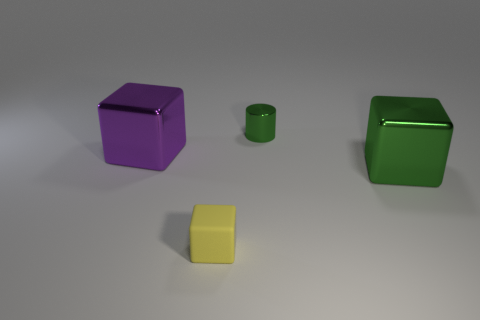What is the material of the big purple thing that is the same shape as the tiny matte object?
Provide a short and direct response. Metal. What is the small green object made of?
Your answer should be very brief. Metal. There is a green object behind the large cube that is in front of the large object to the left of the small shiny cylinder; what is it made of?
Provide a short and direct response. Metal. Is there a metallic cube that has the same color as the shiny cylinder?
Your answer should be very brief. Yes. The green cylinder is what size?
Offer a terse response. Small. Do the yellow cube and the cylinder have the same material?
Ensure brevity in your answer.  No. How many big things are on the left side of the green metal thing that is to the left of the block that is on the right side of the small matte object?
Make the answer very short. 1. There is a green thing left of the big green cube; what shape is it?
Make the answer very short. Cylinder. How many other objects are there of the same material as the yellow thing?
Ensure brevity in your answer.  0. Is the number of green objects that are in front of the big green object less than the number of purple objects that are behind the tiny cylinder?
Give a very brief answer. No. 